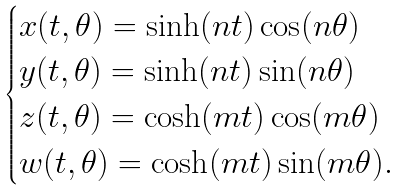Convert formula to latex. <formula><loc_0><loc_0><loc_500><loc_500>\begin{cases} x ( t , \theta ) = \sinh ( n t ) \cos ( n \theta ) & \\ y ( t , \theta ) = \sinh ( n t ) \sin ( n \theta ) & \\ z ( t , \theta ) = \cosh ( m t ) \cos ( m \theta ) & \\ w ( t , \theta ) = \cosh ( m t ) \sin ( m \theta ) . & \\ \end{cases}</formula> 